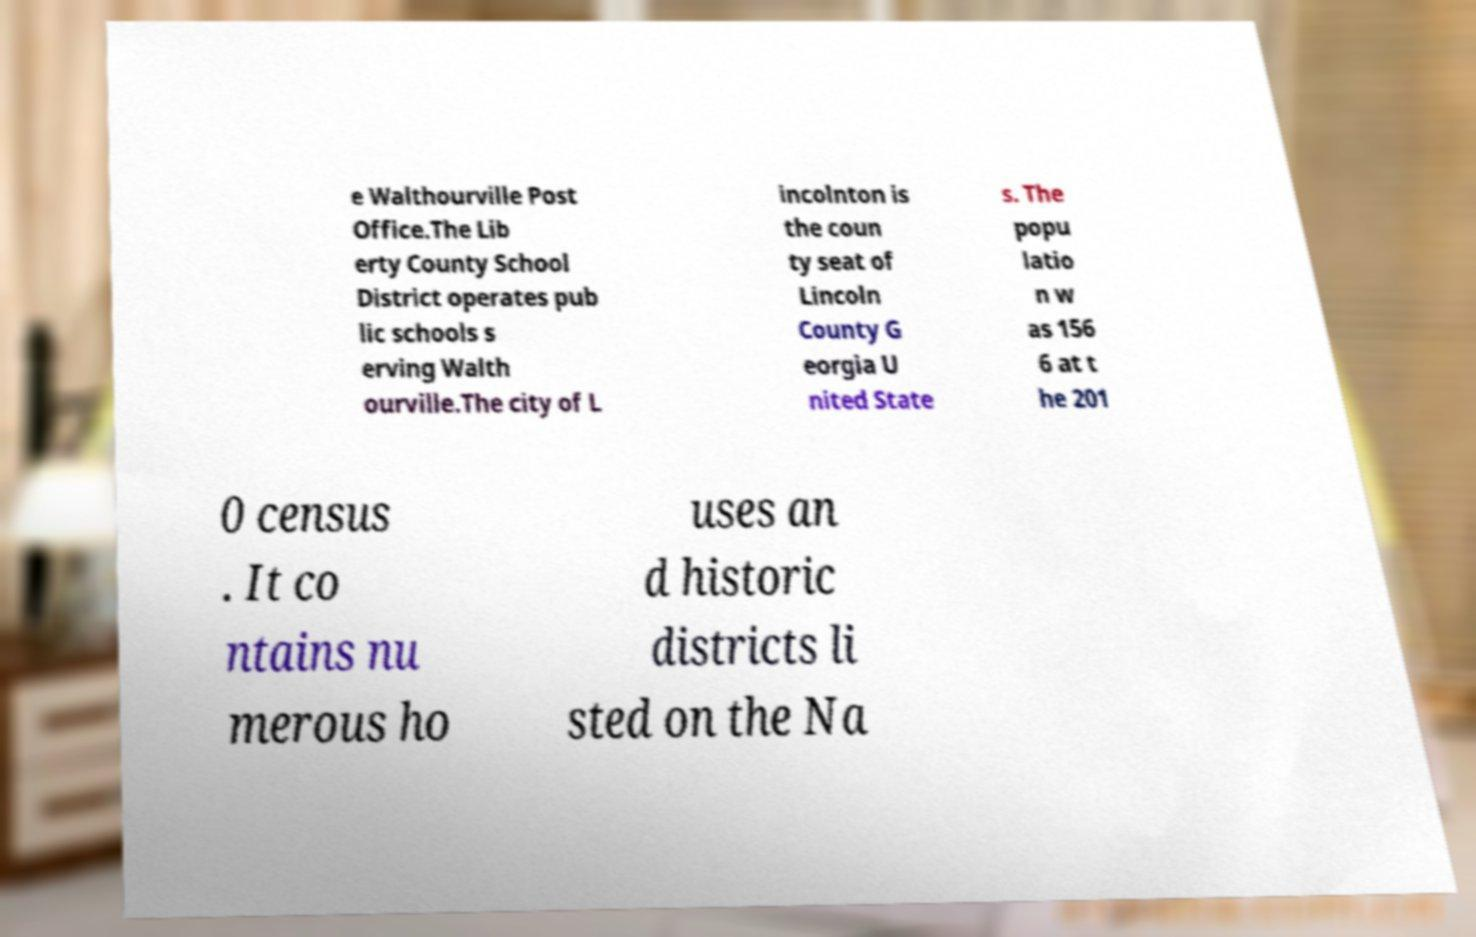Could you extract and type out the text from this image? e Walthourville Post Office.The Lib erty County School District operates pub lic schools s erving Walth ourville.The city of L incolnton is the coun ty seat of Lincoln County G eorgia U nited State s. The popu latio n w as 156 6 at t he 201 0 census . It co ntains nu merous ho uses an d historic districts li sted on the Na 